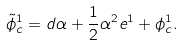Convert formula to latex. <formula><loc_0><loc_0><loc_500><loc_500>\tilde { \phi } _ { c } ^ { 1 } = d \alpha + \frac { 1 } { 2 } \alpha ^ { 2 } e ^ { 1 } + \phi _ { c } ^ { 1 } .</formula> 